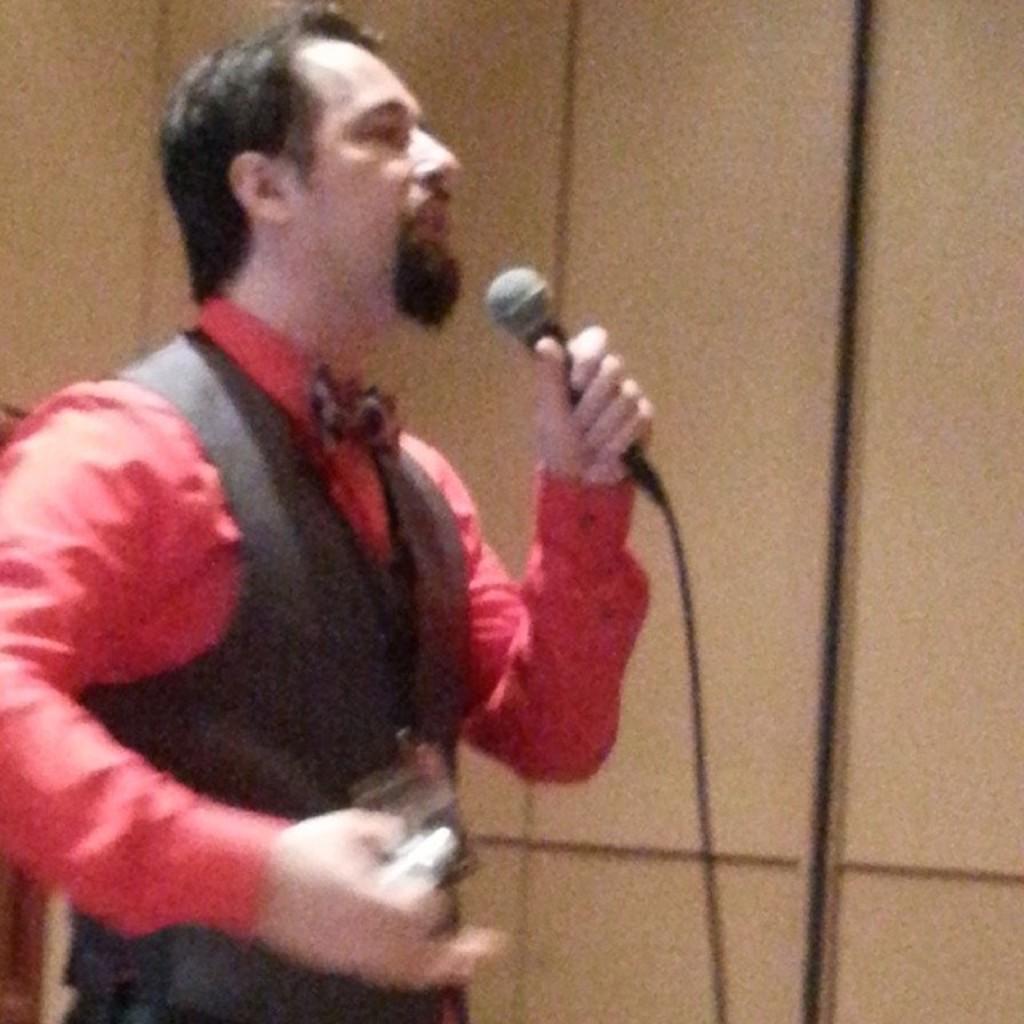How would you summarize this image in a sentence or two? This image contains a person holding a mike wearing a red shirt and black suit. 